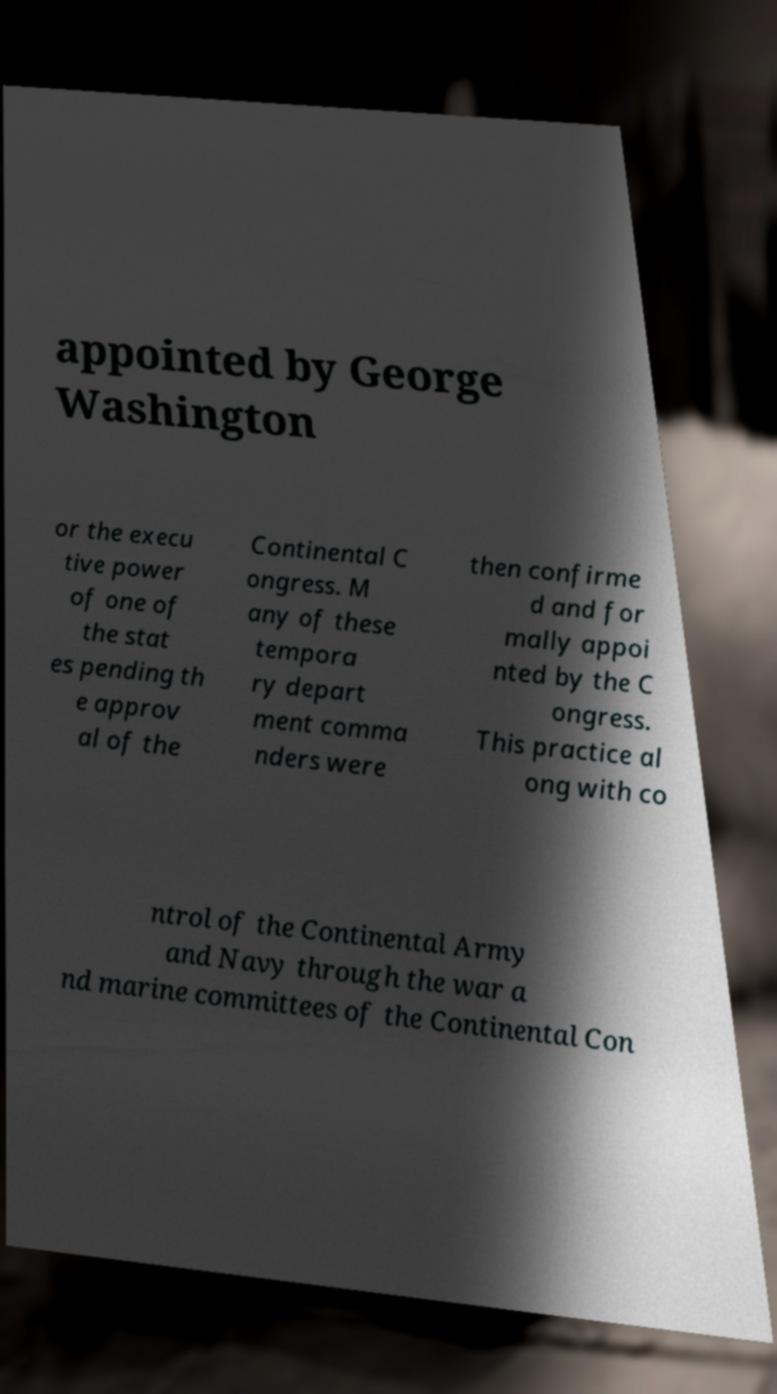Could you assist in decoding the text presented in this image and type it out clearly? appointed by George Washington or the execu tive power of one of the stat es pending th e approv al of the Continental C ongress. M any of these tempora ry depart ment comma nders were then confirme d and for mally appoi nted by the C ongress. This practice al ong with co ntrol of the Continental Army and Navy through the war a nd marine committees of the Continental Con 